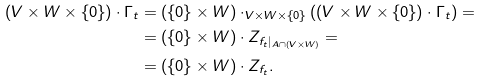<formula> <loc_0><loc_0><loc_500><loc_500>( V \times W \times \{ 0 \} ) \cdot \Gamma _ { t } & = ( \{ 0 \} \times W ) \cdot _ { V \times W \times \{ 0 \} } ( ( V \times W \times \{ 0 \} ) \cdot \Gamma _ { t } ) = \\ & = ( \{ 0 \} \times W ) \cdot Z _ { f _ { t } | _ { A \cap ( V \times W ) } } = \\ & = ( \{ 0 \} \times W ) \cdot Z _ { f _ { t } } .</formula> 